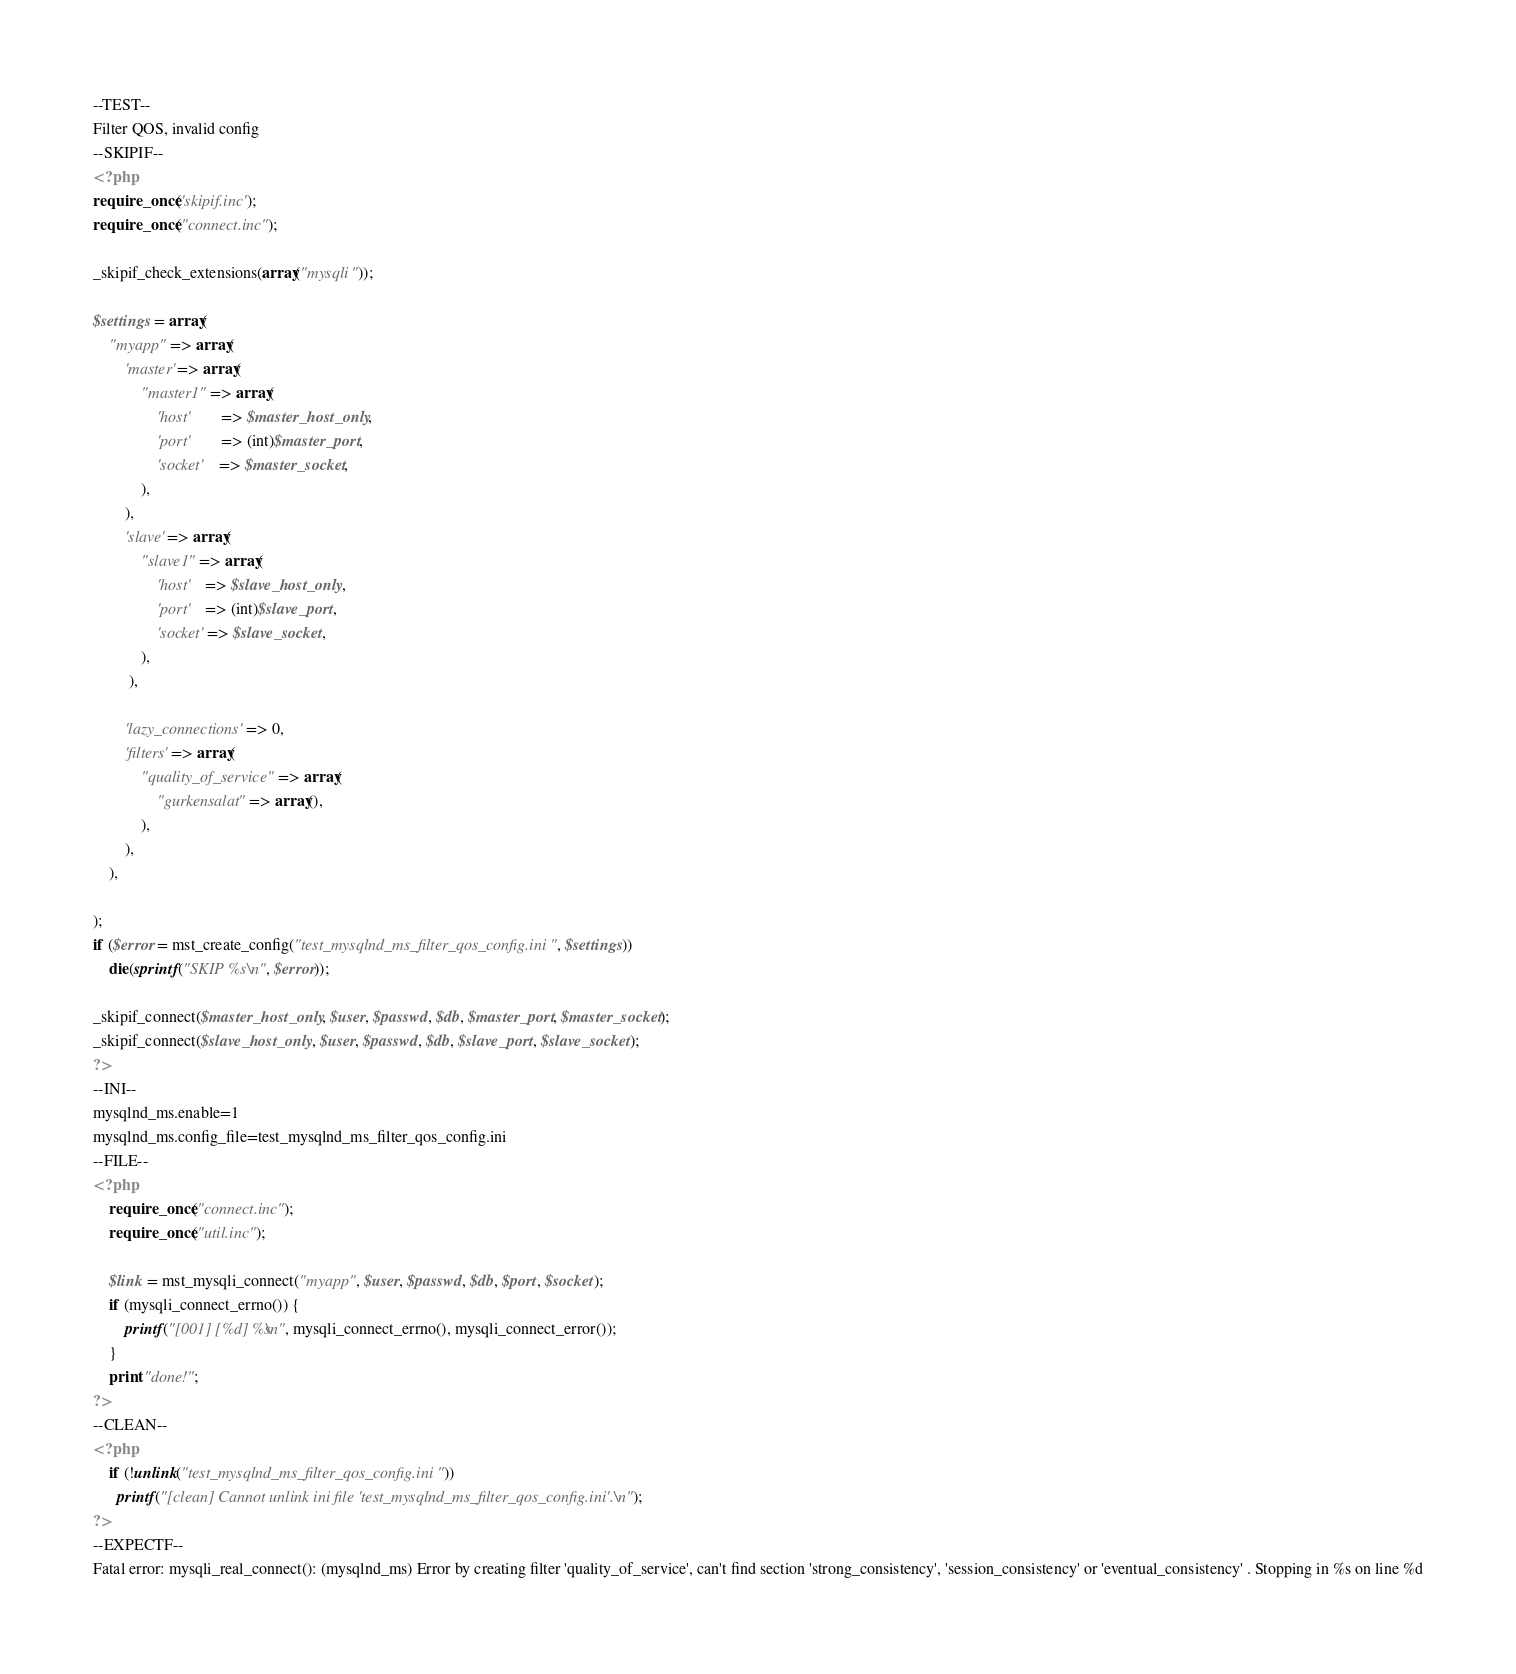<code> <loc_0><loc_0><loc_500><loc_500><_PHP_>--TEST--
Filter QOS, invalid config
--SKIPIF--
<?php
require_once('skipif.inc');
require_once("connect.inc");

_skipif_check_extensions(array("mysqli"));

$settings = array(
	"myapp" => array(
		'master' => array(
			"master1" => array(
				'host' 		=> $master_host_only,
				'port' 		=> (int)$master_port,
				'socket' 	=> $master_socket,
			),
		),
		'slave' => array(
			"slave1" => array(
				'host' 	=> $slave_host_only,
				'port' 	=> (int)$slave_port,
				'socket' => $slave_socket,
			),
		 ),

		'lazy_connections' => 0,
		'filters' => array(
			"quality_of_service" => array(
				"gurkensalat" => array(),
			),
		),
	),

);
if ($error = mst_create_config("test_mysqlnd_ms_filter_qos_config.ini", $settings))
	die(sprintf("SKIP %s\n", $error));

_skipif_connect($master_host_only, $user, $passwd, $db, $master_port, $master_socket);
_skipif_connect($slave_host_only, $user, $passwd, $db, $slave_port, $slave_socket);
?>
--INI--
mysqlnd_ms.enable=1
mysqlnd_ms.config_file=test_mysqlnd_ms_filter_qos_config.ini
--FILE--
<?php
	require_once("connect.inc");
	require_once("util.inc");

	$link = mst_mysqli_connect("myapp", $user, $passwd, $db, $port, $socket);
	if (mysqli_connect_errno()) {
		printf("[001] [%d] %s\n", mysqli_connect_errno(), mysqli_connect_error());
	}
	print "done!";
?>
--CLEAN--
<?php
	if (!unlink("test_mysqlnd_ms_filter_qos_config.ini"))
	  printf("[clean] Cannot unlink ini file 'test_mysqlnd_ms_filter_qos_config.ini'.\n");
?>
--EXPECTF--
Fatal error: mysqli_real_connect(): (mysqlnd_ms) Error by creating filter 'quality_of_service', can't find section 'strong_consistency', 'session_consistency' or 'eventual_consistency' . Stopping in %s on line %d</code> 